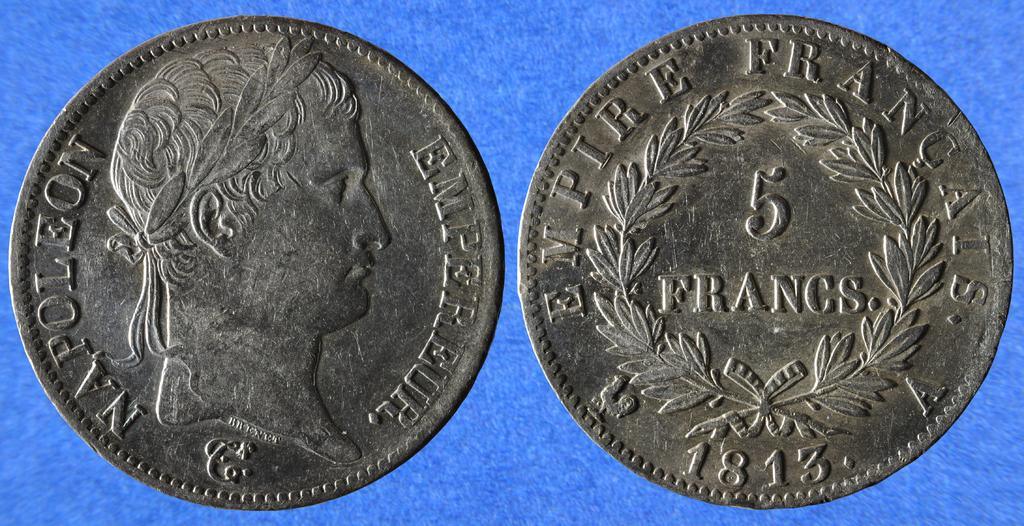Provide a one-sentence caption for the provided image. The head and tails of a Napoleon 5 Francs coin from 1813. 